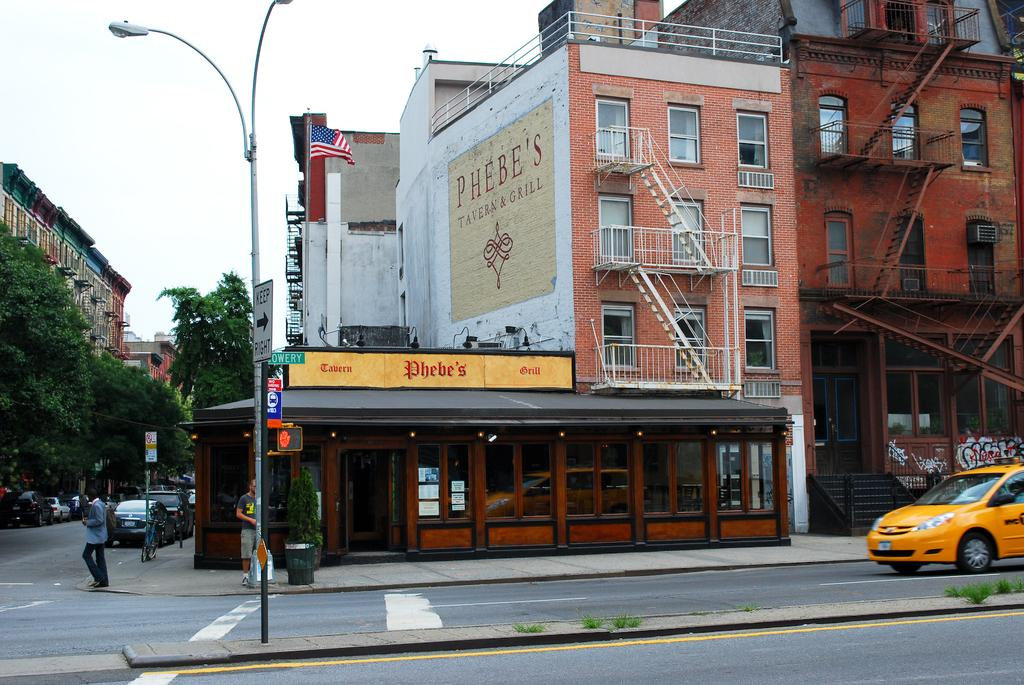<image>
Offer a succinct explanation of the picture presented. The street view of the Phebe's Tavern and Grill facade. 